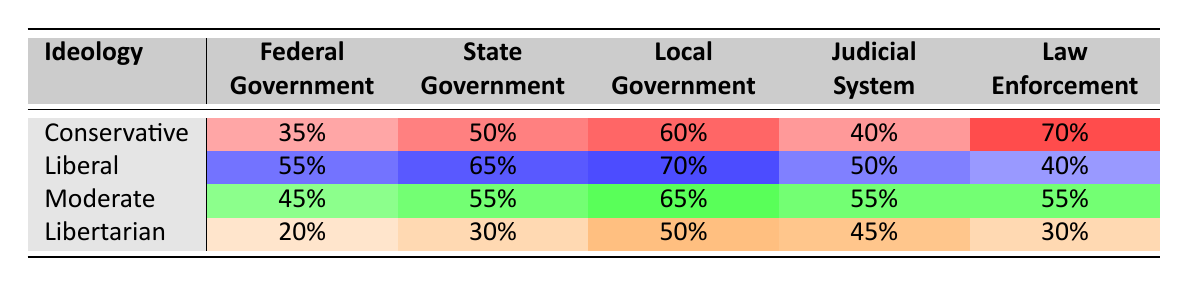What is the trust level in the Local Government for Conservatives? The table indicates that Conservatives have a trust level of 60% in the Local Government.
Answer: 60% Which political ideology has the highest trust level in the Federal Government? The Liberals have a trust level of 55% in the Federal Government, which is the highest compared to the other ideologies listed (Conservative 35%, Moderate 45%, Libertarian 20%).
Answer: Liberal What is the average trust level in Law Enforcement across all political ideologies? To find the average, sum the trust levels: (70 + 40 + 55 + 30)/4 = 48.75, so the average is approximately 48.8%.
Answer: 48.75% Is it true that Moderates trust the Federal Government more than Conservatives? Yes, Conservatives trust the Federal Government at 35%, while Moderates trust it at 45%, which confirms that Moderates have a higher trust level.
Answer: Yes What is the difference in trust level between Liberals and Libertarians for the State Government? Liberals have a trust level of 65% while Libertarians have 30%. The difference is calculated as 65 - 30 = 35%.
Answer: 35% Which ideology shows the least trust in Law Enforcement? The table shows that Libertarians have the lowest trust level in Law Enforcement at 30%, compared to Conservatives (70%), Liberals (40%), and Moderates (55%).
Answer: Libertarian How do the trust levels in the Judicial System compare between Conservatives and Moderates? Conservatives trust the Judicial System at 40%, while Moderates have a higher trust level of 55%. The difference indicates that Moderates trust the system more than Conservatives.
Answer: Moderates trust more What is the total trust level in the Local Government for all ideologies combined? To find the total, sum the trust levels: 60 + 70 + 65 + 50 = 245. The total trust in Local Government across all ideologies is 245%.
Answer: 245 Do both Liberals and Moderates have trust levels above 50% in the State Government? Yes, both Liberals (65%) and Moderates (55%) have trust levels above 50% in the State Government, indicating a common higher trust.
Answer: Yes 